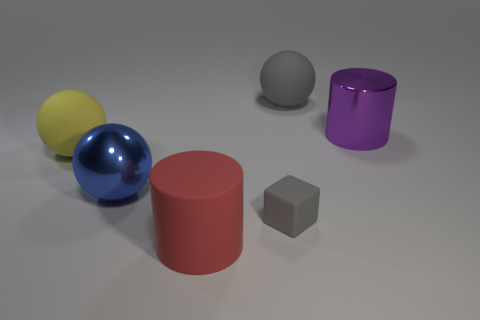There is a large thing that is the same color as the small matte thing; what shape is it?
Your answer should be very brief. Sphere. What is the object that is to the left of the tiny rubber cube and to the right of the large blue shiny thing made of?
Offer a terse response. Rubber. What is the size of the metallic cylinder?
Give a very brief answer. Large. The other large object that is the same shape as the purple shiny thing is what color?
Provide a short and direct response. Red. Is there anything else that has the same color as the tiny block?
Your response must be concise. Yes. There is a gray thing that is in front of the big shiny sphere; does it have the same size as the gray rubber thing that is behind the rubber cube?
Offer a very short reply. No. Is the number of large metallic balls that are in front of the red cylinder the same as the number of small gray matte objects that are in front of the tiny cube?
Keep it short and to the point. Yes. There is a blue metallic object; does it have the same size as the matte object behind the big purple cylinder?
Keep it short and to the point. Yes. Are there any gray rubber blocks to the right of the big matte ball on the left side of the small gray rubber block?
Give a very brief answer. Yes. Is there another object of the same shape as the purple metallic thing?
Give a very brief answer. Yes. 